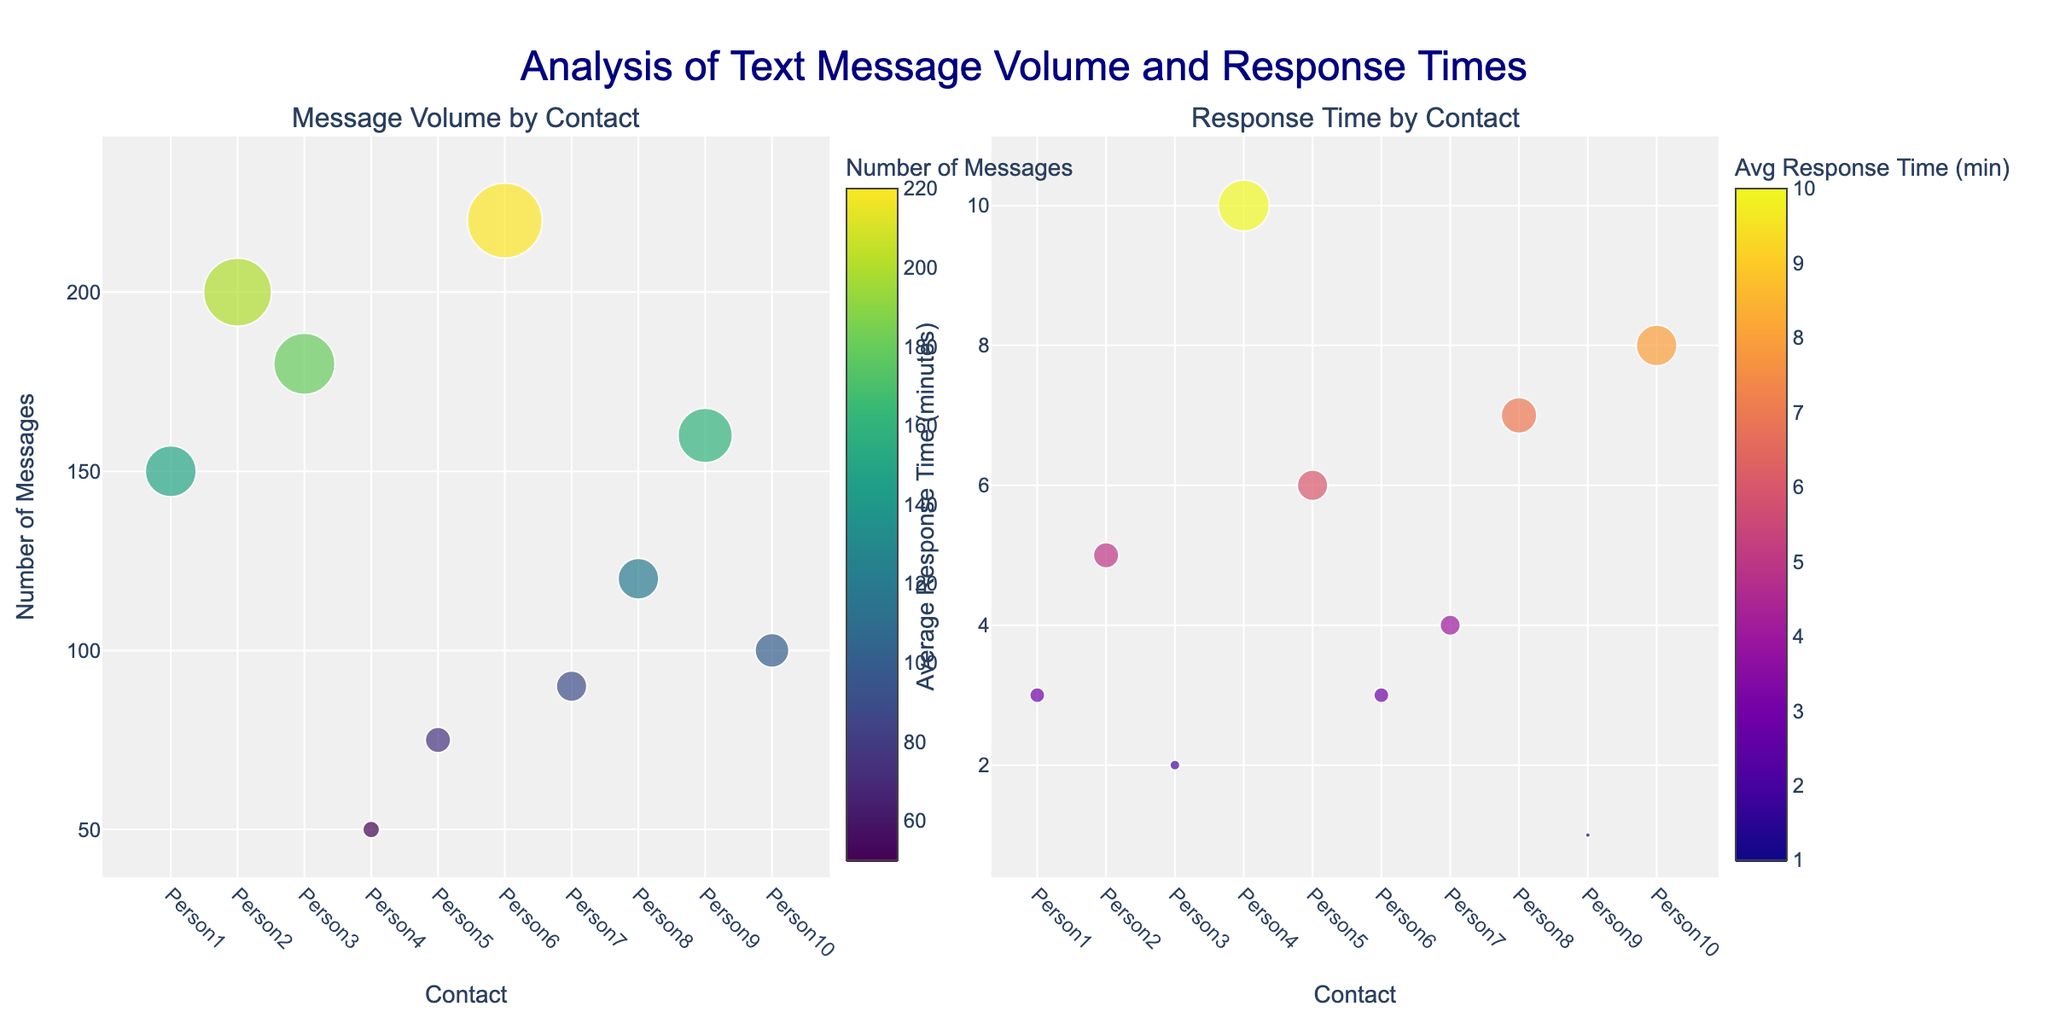What is the title of the figure? The title is displayed at the top center of the figure in a larger font. It reads "Analysis of Text Message Volume and Response Times."
Answer: Analysis of Text Message Volume and Response Times Which contact has the highest number of messages? By observing the scatter plot in the first subplot titled "Message Volume by Contact," the contact with the highest y-value corresponds to Person6.
Answer: Person6 Which contact has the lowest average response time? Referring to the second subplot titled "Response Time by Contact," the contact with the smallest y-value is Person9.
Answer: Person9 How many data points are under the "Response Time by Contact" subplot? By counting the markers in the second subplot, there are 10 data points, each representing a different contact.
Answer: 10 Is there any contact that appears to have a high number of messages and a low average response time? Looking for contacts with high y-values in the first subplot and low y-values in the second subplot, Person6 has a high number of messages (220) and a low average response time (3 minutes).
Answer: Person6 Compare the message volume of Person2 and Person7. Which one has more messages, and by how much? Referring to the first subplot, Person2 has 200 messages, while Person7 has 90 messages. The difference is 200 - 90 = 110. Therefore, Person2 has 110 more messages than Person7.
Answer: Person2, 110 more messages Calculate the average number of messages across all contacts. Sum up the number of messages for all contacts (150 + 200 + 180 + 50 + 75 + 220 + 90 + 120 + 160 + 100) = 1345, then divide by the total number of contacts (10). The average number of messages is 1345 / 10 = 134.5.
Answer: 134.5 Which contact has the longest average response time? By observing the y-values in the second subplot, the contact with the highest average response time is Person4 with 10 minutes.
Answer: Person4 Are the colors used in the two subplots identical? The colorscales for the two subplots are different. The first uses "Viridis" for message volume, while the second uses "Plasma" for average response time.
Answer: No Is there a person with exactly the same number of messages (y-values) as their average response time (y-values in the second plot)? By comparing values from both subplots, no contact has the exact same y-value for the number of messages and average response time.
Answer: No 